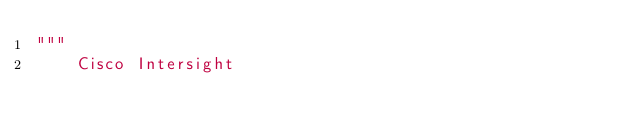<code> <loc_0><loc_0><loc_500><loc_500><_Python_>"""
    Cisco Intersight
</code> 